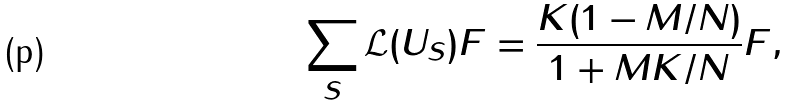Convert formula to latex. <formula><loc_0><loc_0><loc_500><loc_500>\sum _ { S } \mathcal { L } ( U _ { S } ) F = \frac { K ( 1 - M / N ) } { 1 + M K / N } F ,</formula> 